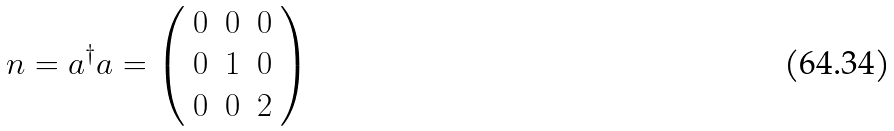<formula> <loc_0><loc_0><loc_500><loc_500>n = a ^ { \dagger } a = \left ( \begin{array} { c c c } 0 & 0 & 0 \\ 0 & 1 & 0 \\ 0 & 0 & 2 \end{array} \right )</formula> 